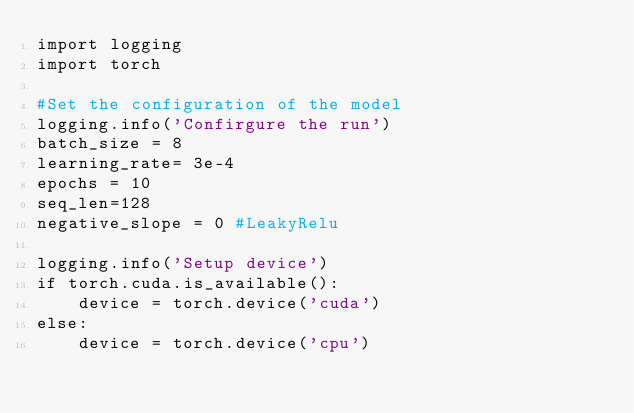Convert code to text. <code><loc_0><loc_0><loc_500><loc_500><_Python_>import logging
import torch

#Set the configuration of the model 
logging.info('Confirgure the run')
batch_size = 8
learning_rate= 3e-4
epochs = 10
seq_len=128
negative_slope = 0 #LeakyRelu

logging.info('Setup device')
if torch.cuda.is_available():
    device = torch.device('cuda')
else:
    device = torch.device('cpu')</code> 